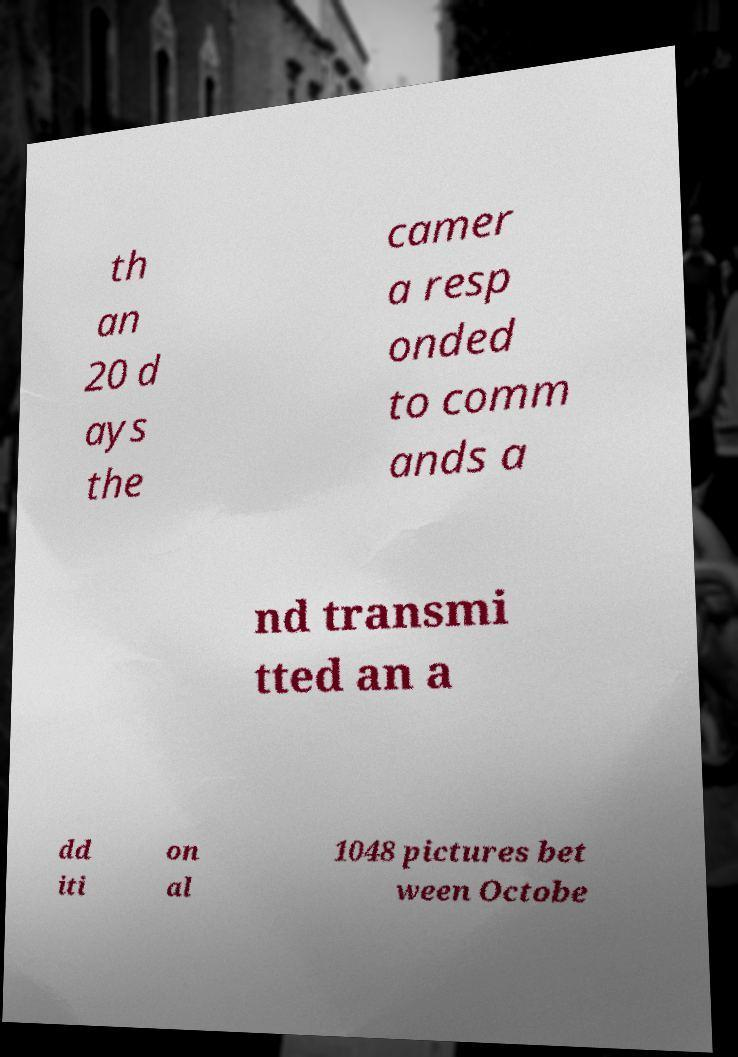What messages or text are displayed in this image? I need them in a readable, typed format. th an 20 d ays the camer a resp onded to comm ands a nd transmi tted an a dd iti on al 1048 pictures bet ween Octobe 